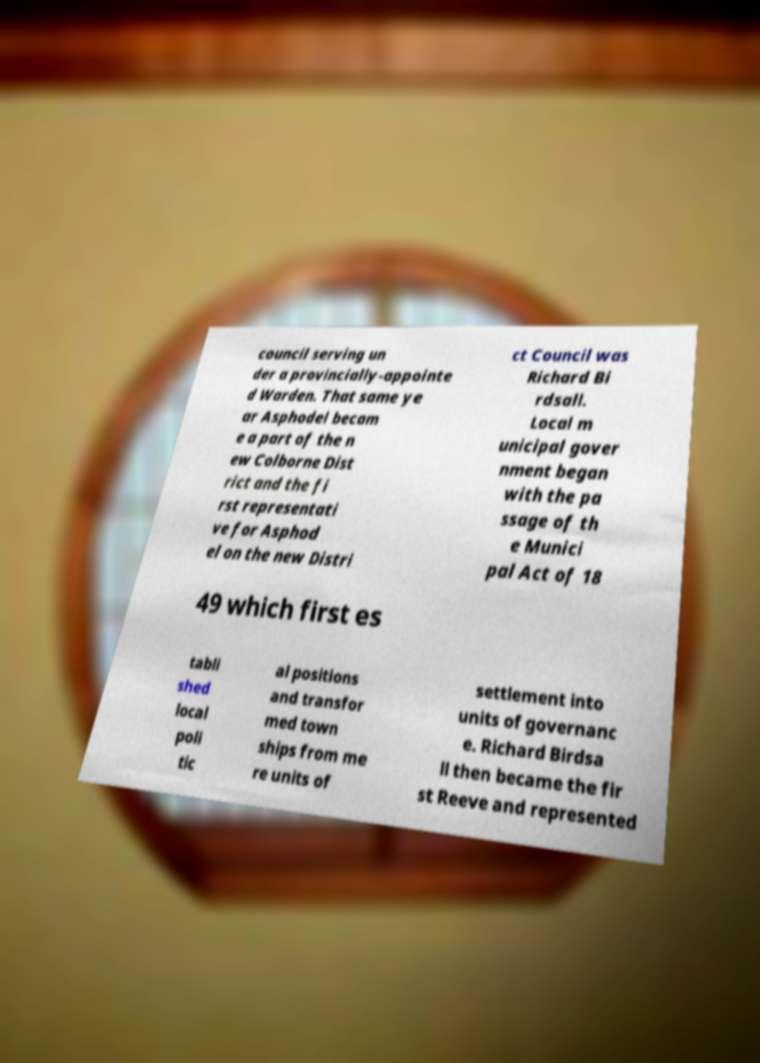Please identify and transcribe the text found in this image. council serving un der a provincially-appointe d Warden. That same ye ar Asphodel becam e a part of the n ew Colborne Dist rict and the fi rst representati ve for Asphod el on the new Distri ct Council was Richard Bi rdsall. Local m unicipal gover nment began with the pa ssage of th e Munici pal Act of 18 49 which first es tabli shed local poli tic al positions and transfor med town ships from me re units of settlement into units of governanc e. Richard Birdsa ll then became the fir st Reeve and represented 